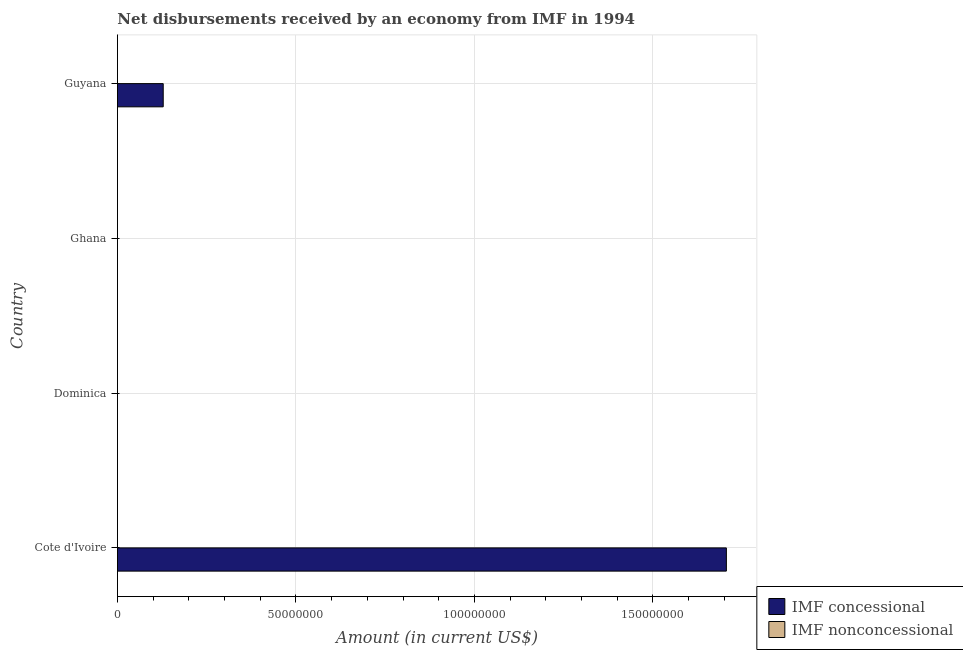Are the number of bars on each tick of the Y-axis equal?
Provide a succinct answer. No. How many bars are there on the 4th tick from the bottom?
Your answer should be compact. 1. What is the label of the 3rd group of bars from the top?
Offer a very short reply. Dominica. In how many cases, is the number of bars for a given country not equal to the number of legend labels?
Your answer should be compact. 4. What is the net concessional disbursements from imf in Guyana?
Provide a succinct answer. 1.28e+07. Across all countries, what is the maximum net concessional disbursements from imf?
Your answer should be compact. 1.71e+08. Across all countries, what is the minimum net non concessional disbursements from imf?
Give a very brief answer. 0. In which country was the net concessional disbursements from imf maximum?
Offer a very short reply. Cote d'Ivoire. What is the difference between the net concessional disbursements from imf in Guyana and the net non concessional disbursements from imf in Ghana?
Make the answer very short. 1.28e+07. What is the average net non concessional disbursements from imf per country?
Keep it short and to the point. 0. What is the ratio of the net concessional disbursements from imf in Cote d'Ivoire to that in Guyana?
Offer a very short reply. 13.29. What is the difference between the highest and the lowest net concessional disbursements from imf?
Provide a succinct answer. 1.71e+08. How many bars are there?
Your answer should be compact. 2. Are all the bars in the graph horizontal?
Ensure brevity in your answer.  Yes. Are the values on the major ticks of X-axis written in scientific E-notation?
Your answer should be very brief. No. Does the graph contain any zero values?
Keep it short and to the point. Yes. Does the graph contain grids?
Give a very brief answer. Yes. How are the legend labels stacked?
Give a very brief answer. Vertical. What is the title of the graph?
Ensure brevity in your answer.  Net disbursements received by an economy from IMF in 1994. What is the Amount (in current US$) in IMF concessional in Cote d'Ivoire?
Keep it short and to the point. 1.71e+08. What is the Amount (in current US$) in IMF nonconcessional in Cote d'Ivoire?
Your answer should be compact. 0. What is the Amount (in current US$) in IMF concessional in Dominica?
Provide a succinct answer. 0. What is the Amount (in current US$) of IMF concessional in Guyana?
Offer a very short reply. 1.28e+07. What is the Amount (in current US$) of IMF nonconcessional in Guyana?
Your response must be concise. 0. Across all countries, what is the maximum Amount (in current US$) of IMF concessional?
Keep it short and to the point. 1.71e+08. What is the total Amount (in current US$) in IMF concessional in the graph?
Offer a terse response. 1.83e+08. What is the difference between the Amount (in current US$) of IMF concessional in Cote d'Ivoire and that in Guyana?
Make the answer very short. 1.58e+08. What is the average Amount (in current US$) of IMF concessional per country?
Ensure brevity in your answer.  4.58e+07. What is the ratio of the Amount (in current US$) of IMF concessional in Cote d'Ivoire to that in Guyana?
Give a very brief answer. 13.29. What is the difference between the highest and the lowest Amount (in current US$) of IMF concessional?
Your answer should be compact. 1.71e+08. 